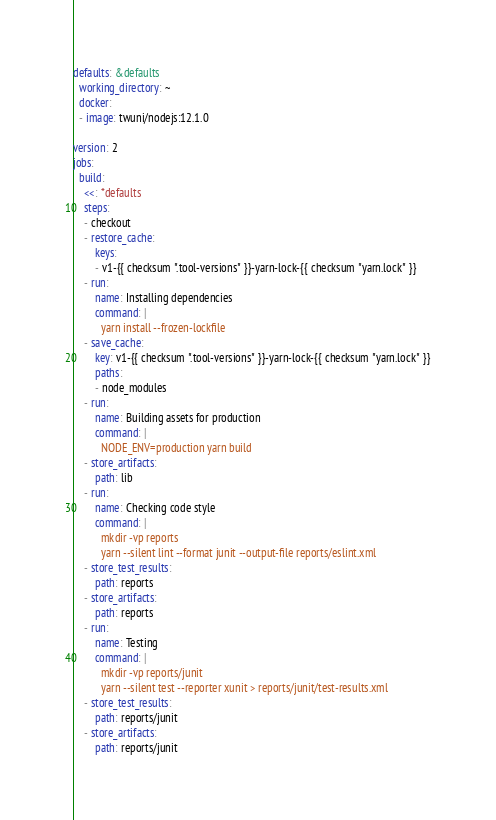Convert code to text. <code><loc_0><loc_0><loc_500><loc_500><_YAML_>defaults: &defaults
  working_directory: ~
  docker:
  - image: twuni/nodejs:12.1.0

version: 2
jobs:
  build:
    <<: *defaults
    steps:
    - checkout
    - restore_cache:
        keys:
        - v1-{{ checksum ".tool-versions" }}-yarn-lock-{{ checksum "yarn.lock" }}
    - run:
        name: Installing dependencies
        command: |
          yarn install --frozen-lockfile
    - save_cache:
        key: v1-{{ checksum ".tool-versions" }}-yarn-lock-{{ checksum "yarn.lock" }}
        paths:
        - node_modules
    - run:
        name: Building assets for production
        command: |
          NODE_ENV=production yarn build
    - store_artifacts:
        path: lib
    - run:
        name: Checking code style
        command: |
          mkdir -vp reports
          yarn --silent lint --format junit --output-file reports/eslint.xml
    - store_test_results:
        path: reports
    - store_artifacts:
        path: reports
    - run:
        name: Testing
        command: |
          mkdir -vp reports/junit
          yarn --silent test --reporter xunit > reports/junit/test-results.xml
    - store_test_results:
        path: reports/junit
    - store_artifacts:
        path: reports/junit
</code> 